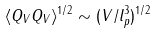<formula> <loc_0><loc_0><loc_500><loc_500>\langle Q _ { V } Q _ { V } \rangle ^ { 1 / 2 } \sim ( V / l _ { p } ^ { 3 } ) ^ { 1 / 2 }</formula> 